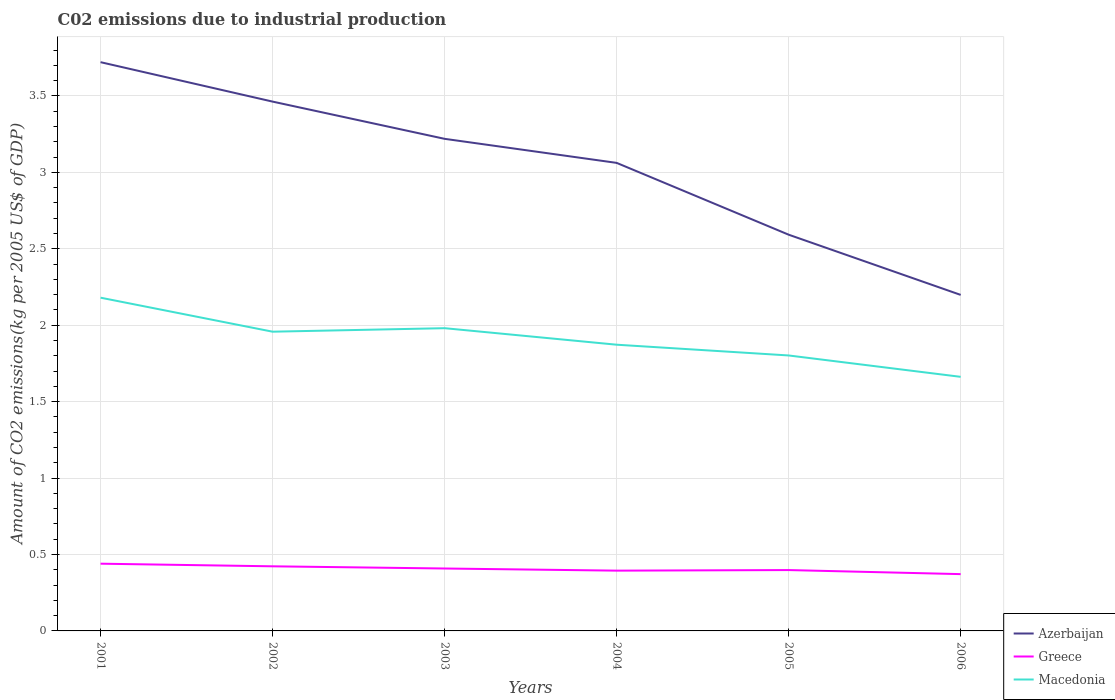How many different coloured lines are there?
Make the answer very short. 3. Does the line corresponding to Greece intersect with the line corresponding to Azerbaijan?
Your answer should be very brief. No. Across all years, what is the maximum amount of CO2 emitted due to industrial production in Macedonia?
Offer a terse response. 1.66. What is the total amount of CO2 emitted due to industrial production in Azerbaijan in the graph?
Your response must be concise. 1.52. What is the difference between the highest and the second highest amount of CO2 emitted due to industrial production in Greece?
Offer a very short reply. 0.07. What is the difference between the highest and the lowest amount of CO2 emitted due to industrial production in Greece?
Give a very brief answer. 3. How many lines are there?
Keep it short and to the point. 3. How many years are there in the graph?
Your answer should be compact. 6. What is the difference between two consecutive major ticks on the Y-axis?
Provide a short and direct response. 0.5. Does the graph contain any zero values?
Provide a short and direct response. No. Where does the legend appear in the graph?
Your response must be concise. Bottom right. How are the legend labels stacked?
Provide a succinct answer. Vertical. What is the title of the graph?
Offer a terse response. C02 emissions due to industrial production. Does "Poland" appear as one of the legend labels in the graph?
Give a very brief answer. No. What is the label or title of the X-axis?
Your answer should be very brief. Years. What is the label or title of the Y-axis?
Keep it short and to the point. Amount of CO2 emissions(kg per 2005 US$ of GDP). What is the Amount of CO2 emissions(kg per 2005 US$ of GDP) in Azerbaijan in 2001?
Make the answer very short. 3.72. What is the Amount of CO2 emissions(kg per 2005 US$ of GDP) of Greece in 2001?
Offer a terse response. 0.44. What is the Amount of CO2 emissions(kg per 2005 US$ of GDP) in Macedonia in 2001?
Offer a very short reply. 2.18. What is the Amount of CO2 emissions(kg per 2005 US$ of GDP) of Azerbaijan in 2002?
Keep it short and to the point. 3.46. What is the Amount of CO2 emissions(kg per 2005 US$ of GDP) in Greece in 2002?
Provide a short and direct response. 0.42. What is the Amount of CO2 emissions(kg per 2005 US$ of GDP) of Macedonia in 2002?
Your answer should be compact. 1.96. What is the Amount of CO2 emissions(kg per 2005 US$ of GDP) of Azerbaijan in 2003?
Offer a very short reply. 3.22. What is the Amount of CO2 emissions(kg per 2005 US$ of GDP) of Greece in 2003?
Make the answer very short. 0.41. What is the Amount of CO2 emissions(kg per 2005 US$ of GDP) of Macedonia in 2003?
Ensure brevity in your answer.  1.98. What is the Amount of CO2 emissions(kg per 2005 US$ of GDP) in Azerbaijan in 2004?
Offer a terse response. 3.06. What is the Amount of CO2 emissions(kg per 2005 US$ of GDP) in Greece in 2004?
Provide a succinct answer. 0.39. What is the Amount of CO2 emissions(kg per 2005 US$ of GDP) of Macedonia in 2004?
Keep it short and to the point. 1.87. What is the Amount of CO2 emissions(kg per 2005 US$ of GDP) in Azerbaijan in 2005?
Provide a succinct answer. 2.59. What is the Amount of CO2 emissions(kg per 2005 US$ of GDP) in Greece in 2005?
Your answer should be very brief. 0.4. What is the Amount of CO2 emissions(kg per 2005 US$ of GDP) in Macedonia in 2005?
Provide a short and direct response. 1.8. What is the Amount of CO2 emissions(kg per 2005 US$ of GDP) of Azerbaijan in 2006?
Your answer should be compact. 2.2. What is the Amount of CO2 emissions(kg per 2005 US$ of GDP) of Greece in 2006?
Ensure brevity in your answer.  0.37. What is the Amount of CO2 emissions(kg per 2005 US$ of GDP) of Macedonia in 2006?
Give a very brief answer. 1.66. Across all years, what is the maximum Amount of CO2 emissions(kg per 2005 US$ of GDP) in Azerbaijan?
Ensure brevity in your answer.  3.72. Across all years, what is the maximum Amount of CO2 emissions(kg per 2005 US$ of GDP) of Greece?
Ensure brevity in your answer.  0.44. Across all years, what is the maximum Amount of CO2 emissions(kg per 2005 US$ of GDP) of Macedonia?
Your answer should be very brief. 2.18. Across all years, what is the minimum Amount of CO2 emissions(kg per 2005 US$ of GDP) of Azerbaijan?
Make the answer very short. 2.2. Across all years, what is the minimum Amount of CO2 emissions(kg per 2005 US$ of GDP) of Greece?
Your response must be concise. 0.37. Across all years, what is the minimum Amount of CO2 emissions(kg per 2005 US$ of GDP) in Macedonia?
Make the answer very short. 1.66. What is the total Amount of CO2 emissions(kg per 2005 US$ of GDP) of Azerbaijan in the graph?
Give a very brief answer. 18.26. What is the total Amount of CO2 emissions(kg per 2005 US$ of GDP) in Greece in the graph?
Ensure brevity in your answer.  2.44. What is the total Amount of CO2 emissions(kg per 2005 US$ of GDP) in Macedonia in the graph?
Offer a terse response. 11.46. What is the difference between the Amount of CO2 emissions(kg per 2005 US$ of GDP) of Azerbaijan in 2001 and that in 2002?
Your answer should be very brief. 0.26. What is the difference between the Amount of CO2 emissions(kg per 2005 US$ of GDP) in Greece in 2001 and that in 2002?
Your response must be concise. 0.02. What is the difference between the Amount of CO2 emissions(kg per 2005 US$ of GDP) in Macedonia in 2001 and that in 2002?
Give a very brief answer. 0.22. What is the difference between the Amount of CO2 emissions(kg per 2005 US$ of GDP) of Azerbaijan in 2001 and that in 2003?
Keep it short and to the point. 0.5. What is the difference between the Amount of CO2 emissions(kg per 2005 US$ of GDP) in Greece in 2001 and that in 2003?
Provide a short and direct response. 0.03. What is the difference between the Amount of CO2 emissions(kg per 2005 US$ of GDP) of Macedonia in 2001 and that in 2003?
Your answer should be very brief. 0.2. What is the difference between the Amount of CO2 emissions(kg per 2005 US$ of GDP) in Azerbaijan in 2001 and that in 2004?
Offer a very short reply. 0.66. What is the difference between the Amount of CO2 emissions(kg per 2005 US$ of GDP) in Greece in 2001 and that in 2004?
Your answer should be compact. 0.05. What is the difference between the Amount of CO2 emissions(kg per 2005 US$ of GDP) in Macedonia in 2001 and that in 2004?
Offer a very short reply. 0.31. What is the difference between the Amount of CO2 emissions(kg per 2005 US$ of GDP) of Azerbaijan in 2001 and that in 2005?
Your response must be concise. 1.13. What is the difference between the Amount of CO2 emissions(kg per 2005 US$ of GDP) in Greece in 2001 and that in 2005?
Your response must be concise. 0.04. What is the difference between the Amount of CO2 emissions(kg per 2005 US$ of GDP) in Macedonia in 2001 and that in 2005?
Provide a succinct answer. 0.38. What is the difference between the Amount of CO2 emissions(kg per 2005 US$ of GDP) of Azerbaijan in 2001 and that in 2006?
Offer a very short reply. 1.52. What is the difference between the Amount of CO2 emissions(kg per 2005 US$ of GDP) of Greece in 2001 and that in 2006?
Your response must be concise. 0.07. What is the difference between the Amount of CO2 emissions(kg per 2005 US$ of GDP) in Macedonia in 2001 and that in 2006?
Your response must be concise. 0.52. What is the difference between the Amount of CO2 emissions(kg per 2005 US$ of GDP) in Azerbaijan in 2002 and that in 2003?
Give a very brief answer. 0.24. What is the difference between the Amount of CO2 emissions(kg per 2005 US$ of GDP) in Greece in 2002 and that in 2003?
Offer a terse response. 0.01. What is the difference between the Amount of CO2 emissions(kg per 2005 US$ of GDP) of Macedonia in 2002 and that in 2003?
Make the answer very short. -0.02. What is the difference between the Amount of CO2 emissions(kg per 2005 US$ of GDP) in Azerbaijan in 2002 and that in 2004?
Offer a terse response. 0.4. What is the difference between the Amount of CO2 emissions(kg per 2005 US$ of GDP) in Greece in 2002 and that in 2004?
Keep it short and to the point. 0.03. What is the difference between the Amount of CO2 emissions(kg per 2005 US$ of GDP) of Macedonia in 2002 and that in 2004?
Keep it short and to the point. 0.09. What is the difference between the Amount of CO2 emissions(kg per 2005 US$ of GDP) in Azerbaijan in 2002 and that in 2005?
Keep it short and to the point. 0.87. What is the difference between the Amount of CO2 emissions(kg per 2005 US$ of GDP) of Greece in 2002 and that in 2005?
Provide a short and direct response. 0.02. What is the difference between the Amount of CO2 emissions(kg per 2005 US$ of GDP) in Macedonia in 2002 and that in 2005?
Offer a very short reply. 0.16. What is the difference between the Amount of CO2 emissions(kg per 2005 US$ of GDP) in Azerbaijan in 2002 and that in 2006?
Offer a very short reply. 1.26. What is the difference between the Amount of CO2 emissions(kg per 2005 US$ of GDP) in Greece in 2002 and that in 2006?
Ensure brevity in your answer.  0.05. What is the difference between the Amount of CO2 emissions(kg per 2005 US$ of GDP) in Macedonia in 2002 and that in 2006?
Give a very brief answer. 0.3. What is the difference between the Amount of CO2 emissions(kg per 2005 US$ of GDP) in Azerbaijan in 2003 and that in 2004?
Provide a succinct answer. 0.16. What is the difference between the Amount of CO2 emissions(kg per 2005 US$ of GDP) in Greece in 2003 and that in 2004?
Provide a short and direct response. 0.01. What is the difference between the Amount of CO2 emissions(kg per 2005 US$ of GDP) of Macedonia in 2003 and that in 2004?
Your response must be concise. 0.11. What is the difference between the Amount of CO2 emissions(kg per 2005 US$ of GDP) in Azerbaijan in 2003 and that in 2005?
Offer a terse response. 0.63. What is the difference between the Amount of CO2 emissions(kg per 2005 US$ of GDP) in Greece in 2003 and that in 2005?
Make the answer very short. 0.01. What is the difference between the Amount of CO2 emissions(kg per 2005 US$ of GDP) in Macedonia in 2003 and that in 2005?
Offer a terse response. 0.18. What is the difference between the Amount of CO2 emissions(kg per 2005 US$ of GDP) of Azerbaijan in 2003 and that in 2006?
Your answer should be compact. 1.02. What is the difference between the Amount of CO2 emissions(kg per 2005 US$ of GDP) in Greece in 2003 and that in 2006?
Provide a succinct answer. 0.04. What is the difference between the Amount of CO2 emissions(kg per 2005 US$ of GDP) of Macedonia in 2003 and that in 2006?
Keep it short and to the point. 0.32. What is the difference between the Amount of CO2 emissions(kg per 2005 US$ of GDP) in Azerbaijan in 2004 and that in 2005?
Offer a very short reply. 0.47. What is the difference between the Amount of CO2 emissions(kg per 2005 US$ of GDP) of Greece in 2004 and that in 2005?
Provide a succinct answer. -0. What is the difference between the Amount of CO2 emissions(kg per 2005 US$ of GDP) of Macedonia in 2004 and that in 2005?
Keep it short and to the point. 0.07. What is the difference between the Amount of CO2 emissions(kg per 2005 US$ of GDP) in Azerbaijan in 2004 and that in 2006?
Ensure brevity in your answer.  0.86. What is the difference between the Amount of CO2 emissions(kg per 2005 US$ of GDP) in Greece in 2004 and that in 2006?
Your answer should be very brief. 0.02. What is the difference between the Amount of CO2 emissions(kg per 2005 US$ of GDP) of Macedonia in 2004 and that in 2006?
Keep it short and to the point. 0.21. What is the difference between the Amount of CO2 emissions(kg per 2005 US$ of GDP) of Azerbaijan in 2005 and that in 2006?
Make the answer very short. 0.39. What is the difference between the Amount of CO2 emissions(kg per 2005 US$ of GDP) in Greece in 2005 and that in 2006?
Offer a terse response. 0.03. What is the difference between the Amount of CO2 emissions(kg per 2005 US$ of GDP) of Macedonia in 2005 and that in 2006?
Offer a very short reply. 0.14. What is the difference between the Amount of CO2 emissions(kg per 2005 US$ of GDP) of Azerbaijan in 2001 and the Amount of CO2 emissions(kg per 2005 US$ of GDP) of Greece in 2002?
Your response must be concise. 3.3. What is the difference between the Amount of CO2 emissions(kg per 2005 US$ of GDP) of Azerbaijan in 2001 and the Amount of CO2 emissions(kg per 2005 US$ of GDP) of Macedonia in 2002?
Provide a succinct answer. 1.76. What is the difference between the Amount of CO2 emissions(kg per 2005 US$ of GDP) in Greece in 2001 and the Amount of CO2 emissions(kg per 2005 US$ of GDP) in Macedonia in 2002?
Provide a short and direct response. -1.52. What is the difference between the Amount of CO2 emissions(kg per 2005 US$ of GDP) in Azerbaijan in 2001 and the Amount of CO2 emissions(kg per 2005 US$ of GDP) in Greece in 2003?
Your response must be concise. 3.31. What is the difference between the Amount of CO2 emissions(kg per 2005 US$ of GDP) in Azerbaijan in 2001 and the Amount of CO2 emissions(kg per 2005 US$ of GDP) in Macedonia in 2003?
Offer a terse response. 1.74. What is the difference between the Amount of CO2 emissions(kg per 2005 US$ of GDP) of Greece in 2001 and the Amount of CO2 emissions(kg per 2005 US$ of GDP) of Macedonia in 2003?
Ensure brevity in your answer.  -1.54. What is the difference between the Amount of CO2 emissions(kg per 2005 US$ of GDP) of Azerbaijan in 2001 and the Amount of CO2 emissions(kg per 2005 US$ of GDP) of Greece in 2004?
Offer a very short reply. 3.33. What is the difference between the Amount of CO2 emissions(kg per 2005 US$ of GDP) of Azerbaijan in 2001 and the Amount of CO2 emissions(kg per 2005 US$ of GDP) of Macedonia in 2004?
Offer a terse response. 1.85. What is the difference between the Amount of CO2 emissions(kg per 2005 US$ of GDP) in Greece in 2001 and the Amount of CO2 emissions(kg per 2005 US$ of GDP) in Macedonia in 2004?
Provide a succinct answer. -1.43. What is the difference between the Amount of CO2 emissions(kg per 2005 US$ of GDP) in Azerbaijan in 2001 and the Amount of CO2 emissions(kg per 2005 US$ of GDP) in Greece in 2005?
Provide a succinct answer. 3.32. What is the difference between the Amount of CO2 emissions(kg per 2005 US$ of GDP) in Azerbaijan in 2001 and the Amount of CO2 emissions(kg per 2005 US$ of GDP) in Macedonia in 2005?
Make the answer very short. 1.92. What is the difference between the Amount of CO2 emissions(kg per 2005 US$ of GDP) of Greece in 2001 and the Amount of CO2 emissions(kg per 2005 US$ of GDP) of Macedonia in 2005?
Provide a short and direct response. -1.36. What is the difference between the Amount of CO2 emissions(kg per 2005 US$ of GDP) of Azerbaijan in 2001 and the Amount of CO2 emissions(kg per 2005 US$ of GDP) of Greece in 2006?
Your response must be concise. 3.35. What is the difference between the Amount of CO2 emissions(kg per 2005 US$ of GDP) in Azerbaijan in 2001 and the Amount of CO2 emissions(kg per 2005 US$ of GDP) in Macedonia in 2006?
Your answer should be very brief. 2.06. What is the difference between the Amount of CO2 emissions(kg per 2005 US$ of GDP) of Greece in 2001 and the Amount of CO2 emissions(kg per 2005 US$ of GDP) of Macedonia in 2006?
Your response must be concise. -1.22. What is the difference between the Amount of CO2 emissions(kg per 2005 US$ of GDP) of Azerbaijan in 2002 and the Amount of CO2 emissions(kg per 2005 US$ of GDP) of Greece in 2003?
Offer a terse response. 3.05. What is the difference between the Amount of CO2 emissions(kg per 2005 US$ of GDP) in Azerbaijan in 2002 and the Amount of CO2 emissions(kg per 2005 US$ of GDP) in Macedonia in 2003?
Your response must be concise. 1.48. What is the difference between the Amount of CO2 emissions(kg per 2005 US$ of GDP) in Greece in 2002 and the Amount of CO2 emissions(kg per 2005 US$ of GDP) in Macedonia in 2003?
Your answer should be very brief. -1.56. What is the difference between the Amount of CO2 emissions(kg per 2005 US$ of GDP) of Azerbaijan in 2002 and the Amount of CO2 emissions(kg per 2005 US$ of GDP) of Greece in 2004?
Your answer should be very brief. 3.07. What is the difference between the Amount of CO2 emissions(kg per 2005 US$ of GDP) in Azerbaijan in 2002 and the Amount of CO2 emissions(kg per 2005 US$ of GDP) in Macedonia in 2004?
Your response must be concise. 1.59. What is the difference between the Amount of CO2 emissions(kg per 2005 US$ of GDP) of Greece in 2002 and the Amount of CO2 emissions(kg per 2005 US$ of GDP) of Macedonia in 2004?
Offer a very short reply. -1.45. What is the difference between the Amount of CO2 emissions(kg per 2005 US$ of GDP) of Azerbaijan in 2002 and the Amount of CO2 emissions(kg per 2005 US$ of GDP) of Greece in 2005?
Your answer should be compact. 3.06. What is the difference between the Amount of CO2 emissions(kg per 2005 US$ of GDP) in Azerbaijan in 2002 and the Amount of CO2 emissions(kg per 2005 US$ of GDP) in Macedonia in 2005?
Your answer should be very brief. 1.66. What is the difference between the Amount of CO2 emissions(kg per 2005 US$ of GDP) of Greece in 2002 and the Amount of CO2 emissions(kg per 2005 US$ of GDP) of Macedonia in 2005?
Your answer should be very brief. -1.38. What is the difference between the Amount of CO2 emissions(kg per 2005 US$ of GDP) of Azerbaijan in 2002 and the Amount of CO2 emissions(kg per 2005 US$ of GDP) of Greece in 2006?
Provide a succinct answer. 3.09. What is the difference between the Amount of CO2 emissions(kg per 2005 US$ of GDP) in Azerbaijan in 2002 and the Amount of CO2 emissions(kg per 2005 US$ of GDP) in Macedonia in 2006?
Provide a short and direct response. 1.8. What is the difference between the Amount of CO2 emissions(kg per 2005 US$ of GDP) in Greece in 2002 and the Amount of CO2 emissions(kg per 2005 US$ of GDP) in Macedonia in 2006?
Your response must be concise. -1.24. What is the difference between the Amount of CO2 emissions(kg per 2005 US$ of GDP) in Azerbaijan in 2003 and the Amount of CO2 emissions(kg per 2005 US$ of GDP) in Greece in 2004?
Your answer should be very brief. 2.83. What is the difference between the Amount of CO2 emissions(kg per 2005 US$ of GDP) in Azerbaijan in 2003 and the Amount of CO2 emissions(kg per 2005 US$ of GDP) in Macedonia in 2004?
Offer a very short reply. 1.35. What is the difference between the Amount of CO2 emissions(kg per 2005 US$ of GDP) of Greece in 2003 and the Amount of CO2 emissions(kg per 2005 US$ of GDP) of Macedonia in 2004?
Your answer should be compact. -1.46. What is the difference between the Amount of CO2 emissions(kg per 2005 US$ of GDP) of Azerbaijan in 2003 and the Amount of CO2 emissions(kg per 2005 US$ of GDP) of Greece in 2005?
Provide a short and direct response. 2.82. What is the difference between the Amount of CO2 emissions(kg per 2005 US$ of GDP) of Azerbaijan in 2003 and the Amount of CO2 emissions(kg per 2005 US$ of GDP) of Macedonia in 2005?
Provide a short and direct response. 1.42. What is the difference between the Amount of CO2 emissions(kg per 2005 US$ of GDP) of Greece in 2003 and the Amount of CO2 emissions(kg per 2005 US$ of GDP) of Macedonia in 2005?
Give a very brief answer. -1.39. What is the difference between the Amount of CO2 emissions(kg per 2005 US$ of GDP) of Azerbaijan in 2003 and the Amount of CO2 emissions(kg per 2005 US$ of GDP) of Greece in 2006?
Provide a succinct answer. 2.85. What is the difference between the Amount of CO2 emissions(kg per 2005 US$ of GDP) in Azerbaijan in 2003 and the Amount of CO2 emissions(kg per 2005 US$ of GDP) in Macedonia in 2006?
Your answer should be compact. 1.56. What is the difference between the Amount of CO2 emissions(kg per 2005 US$ of GDP) of Greece in 2003 and the Amount of CO2 emissions(kg per 2005 US$ of GDP) of Macedonia in 2006?
Give a very brief answer. -1.25. What is the difference between the Amount of CO2 emissions(kg per 2005 US$ of GDP) in Azerbaijan in 2004 and the Amount of CO2 emissions(kg per 2005 US$ of GDP) in Greece in 2005?
Offer a very short reply. 2.66. What is the difference between the Amount of CO2 emissions(kg per 2005 US$ of GDP) of Azerbaijan in 2004 and the Amount of CO2 emissions(kg per 2005 US$ of GDP) of Macedonia in 2005?
Give a very brief answer. 1.26. What is the difference between the Amount of CO2 emissions(kg per 2005 US$ of GDP) in Greece in 2004 and the Amount of CO2 emissions(kg per 2005 US$ of GDP) in Macedonia in 2005?
Keep it short and to the point. -1.41. What is the difference between the Amount of CO2 emissions(kg per 2005 US$ of GDP) in Azerbaijan in 2004 and the Amount of CO2 emissions(kg per 2005 US$ of GDP) in Greece in 2006?
Ensure brevity in your answer.  2.69. What is the difference between the Amount of CO2 emissions(kg per 2005 US$ of GDP) of Azerbaijan in 2004 and the Amount of CO2 emissions(kg per 2005 US$ of GDP) of Macedonia in 2006?
Ensure brevity in your answer.  1.4. What is the difference between the Amount of CO2 emissions(kg per 2005 US$ of GDP) of Greece in 2004 and the Amount of CO2 emissions(kg per 2005 US$ of GDP) of Macedonia in 2006?
Provide a succinct answer. -1.27. What is the difference between the Amount of CO2 emissions(kg per 2005 US$ of GDP) in Azerbaijan in 2005 and the Amount of CO2 emissions(kg per 2005 US$ of GDP) in Greece in 2006?
Your answer should be very brief. 2.22. What is the difference between the Amount of CO2 emissions(kg per 2005 US$ of GDP) in Greece in 2005 and the Amount of CO2 emissions(kg per 2005 US$ of GDP) in Macedonia in 2006?
Ensure brevity in your answer.  -1.26. What is the average Amount of CO2 emissions(kg per 2005 US$ of GDP) of Azerbaijan per year?
Offer a very short reply. 3.04. What is the average Amount of CO2 emissions(kg per 2005 US$ of GDP) in Greece per year?
Keep it short and to the point. 0.41. What is the average Amount of CO2 emissions(kg per 2005 US$ of GDP) of Macedonia per year?
Your answer should be compact. 1.91. In the year 2001, what is the difference between the Amount of CO2 emissions(kg per 2005 US$ of GDP) of Azerbaijan and Amount of CO2 emissions(kg per 2005 US$ of GDP) of Greece?
Your answer should be very brief. 3.28. In the year 2001, what is the difference between the Amount of CO2 emissions(kg per 2005 US$ of GDP) of Azerbaijan and Amount of CO2 emissions(kg per 2005 US$ of GDP) of Macedonia?
Make the answer very short. 1.54. In the year 2001, what is the difference between the Amount of CO2 emissions(kg per 2005 US$ of GDP) in Greece and Amount of CO2 emissions(kg per 2005 US$ of GDP) in Macedonia?
Your answer should be compact. -1.74. In the year 2002, what is the difference between the Amount of CO2 emissions(kg per 2005 US$ of GDP) in Azerbaijan and Amount of CO2 emissions(kg per 2005 US$ of GDP) in Greece?
Ensure brevity in your answer.  3.04. In the year 2002, what is the difference between the Amount of CO2 emissions(kg per 2005 US$ of GDP) in Azerbaijan and Amount of CO2 emissions(kg per 2005 US$ of GDP) in Macedonia?
Offer a terse response. 1.51. In the year 2002, what is the difference between the Amount of CO2 emissions(kg per 2005 US$ of GDP) of Greece and Amount of CO2 emissions(kg per 2005 US$ of GDP) of Macedonia?
Your answer should be very brief. -1.54. In the year 2003, what is the difference between the Amount of CO2 emissions(kg per 2005 US$ of GDP) of Azerbaijan and Amount of CO2 emissions(kg per 2005 US$ of GDP) of Greece?
Your response must be concise. 2.81. In the year 2003, what is the difference between the Amount of CO2 emissions(kg per 2005 US$ of GDP) of Azerbaijan and Amount of CO2 emissions(kg per 2005 US$ of GDP) of Macedonia?
Make the answer very short. 1.24. In the year 2003, what is the difference between the Amount of CO2 emissions(kg per 2005 US$ of GDP) in Greece and Amount of CO2 emissions(kg per 2005 US$ of GDP) in Macedonia?
Keep it short and to the point. -1.57. In the year 2004, what is the difference between the Amount of CO2 emissions(kg per 2005 US$ of GDP) in Azerbaijan and Amount of CO2 emissions(kg per 2005 US$ of GDP) in Greece?
Your response must be concise. 2.67. In the year 2004, what is the difference between the Amount of CO2 emissions(kg per 2005 US$ of GDP) in Azerbaijan and Amount of CO2 emissions(kg per 2005 US$ of GDP) in Macedonia?
Provide a short and direct response. 1.19. In the year 2004, what is the difference between the Amount of CO2 emissions(kg per 2005 US$ of GDP) in Greece and Amount of CO2 emissions(kg per 2005 US$ of GDP) in Macedonia?
Keep it short and to the point. -1.48. In the year 2005, what is the difference between the Amount of CO2 emissions(kg per 2005 US$ of GDP) of Azerbaijan and Amount of CO2 emissions(kg per 2005 US$ of GDP) of Greece?
Your answer should be very brief. 2.19. In the year 2005, what is the difference between the Amount of CO2 emissions(kg per 2005 US$ of GDP) of Azerbaijan and Amount of CO2 emissions(kg per 2005 US$ of GDP) of Macedonia?
Make the answer very short. 0.79. In the year 2005, what is the difference between the Amount of CO2 emissions(kg per 2005 US$ of GDP) of Greece and Amount of CO2 emissions(kg per 2005 US$ of GDP) of Macedonia?
Your answer should be compact. -1.4. In the year 2006, what is the difference between the Amount of CO2 emissions(kg per 2005 US$ of GDP) in Azerbaijan and Amount of CO2 emissions(kg per 2005 US$ of GDP) in Greece?
Provide a succinct answer. 1.83. In the year 2006, what is the difference between the Amount of CO2 emissions(kg per 2005 US$ of GDP) of Azerbaijan and Amount of CO2 emissions(kg per 2005 US$ of GDP) of Macedonia?
Your answer should be compact. 0.54. In the year 2006, what is the difference between the Amount of CO2 emissions(kg per 2005 US$ of GDP) of Greece and Amount of CO2 emissions(kg per 2005 US$ of GDP) of Macedonia?
Your answer should be compact. -1.29. What is the ratio of the Amount of CO2 emissions(kg per 2005 US$ of GDP) in Azerbaijan in 2001 to that in 2002?
Offer a terse response. 1.07. What is the ratio of the Amount of CO2 emissions(kg per 2005 US$ of GDP) of Greece in 2001 to that in 2002?
Make the answer very short. 1.04. What is the ratio of the Amount of CO2 emissions(kg per 2005 US$ of GDP) of Macedonia in 2001 to that in 2002?
Your answer should be very brief. 1.11. What is the ratio of the Amount of CO2 emissions(kg per 2005 US$ of GDP) of Azerbaijan in 2001 to that in 2003?
Provide a succinct answer. 1.16. What is the ratio of the Amount of CO2 emissions(kg per 2005 US$ of GDP) in Greece in 2001 to that in 2003?
Ensure brevity in your answer.  1.08. What is the ratio of the Amount of CO2 emissions(kg per 2005 US$ of GDP) of Macedonia in 2001 to that in 2003?
Your answer should be compact. 1.1. What is the ratio of the Amount of CO2 emissions(kg per 2005 US$ of GDP) in Azerbaijan in 2001 to that in 2004?
Ensure brevity in your answer.  1.22. What is the ratio of the Amount of CO2 emissions(kg per 2005 US$ of GDP) of Greece in 2001 to that in 2004?
Provide a short and direct response. 1.12. What is the ratio of the Amount of CO2 emissions(kg per 2005 US$ of GDP) in Macedonia in 2001 to that in 2004?
Keep it short and to the point. 1.16. What is the ratio of the Amount of CO2 emissions(kg per 2005 US$ of GDP) in Azerbaijan in 2001 to that in 2005?
Your answer should be compact. 1.44. What is the ratio of the Amount of CO2 emissions(kg per 2005 US$ of GDP) in Greece in 2001 to that in 2005?
Provide a succinct answer. 1.1. What is the ratio of the Amount of CO2 emissions(kg per 2005 US$ of GDP) of Macedonia in 2001 to that in 2005?
Your answer should be very brief. 1.21. What is the ratio of the Amount of CO2 emissions(kg per 2005 US$ of GDP) of Azerbaijan in 2001 to that in 2006?
Ensure brevity in your answer.  1.69. What is the ratio of the Amount of CO2 emissions(kg per 2005 US$ of GDP) of Greece in 2001 to that in 2006?
Offer a very short reply. 1.18. What is the ratio of the Amount of CO2 emissions(kg per 2005 US$ of GDP) in Macedonia in 2001 to that in 2006?
Your answer should be compact. 1.31. What is the ratio of the Amount of CO2 emissions(kg per 2005 US$ of GDP) in Azerbaijan in 2002 to that in 2003?
Provide a short and direct response. 1.08. What is the ratio of the Amount of CO2 emissions(kg per 2005 US$ of GDP) of Greece in 2002 to that in 2003?
Your answer should be very brief. 1.04. What is the ratio of the Amount of CO2 emissions(kg per 2005 US$ of GDP) in Macedonia in 2002 to that in 2003?
Your answer should be compact. 0.99. What is the ratio of the Amount of CO2 emissions(kg per 2005 US$ of GDP) of Azerbaijan in 2002 to that in 2004?
Offer a very short reply. 1.13. What is the ratio of the Amount of CO2 emissions(kg per 2005 US$ of GDP) in Greece in 2002 to that in 2004?
Provide a succinct answer. 1.07. What is the ratio of the Amount of CO2 emissions(kg per 2005 US$ of GDP) in Macedonia in 2002 to that in 2004?
Give a very brief answer. 1.05. What is the ratio of the Amount of CO2 emissions(kg per 2005 US$ of GDP) of Azerbaijan in 2002 to that in 2005?
Make the answer very short. 1.34. What is the ratio of the Amount of CO2 emissions(kg per 2005 US$ of GDP) in Greece in 2002 to that in 2005?
Give a very brief answer. 1.06. What is the ratio of the Amount of CO2 emissions(kg per 2005 US$ of GDP) of Macedonia in 2002 to that in 2005?
Offer a very short reply. 1.09. What is the ratio of the Amount of CO2 emissions(kg per 2005 US$ of GDP) in Azerbaijan in 2002 to that in 2006?
Give a very brief answer. 1.58. What is the ratio of the Amount of CO2 emissions(kg per 2005 US$ of GDP) in Greece in 2002 to that in 2006?
Offer a very short reply. 1.14. What is the ratio of the Amount of CO2 emissions(kg per 2005 US$ of GDP) of Macedonia in 2002 to that in 2006?
Make the answer very short. 1.18. What is the ratio of the Amount of CO2 emissions(kg per 2005 US$ of GDP) of Azerbaijan in 2003 to that in 2004?
Offer a terse response. 1.05. What is the ratio of the Amount of CO2 emissions(kg per 2005 US$ of GDP) in Greece in 2003 to that in 2004?
Provide a succinct answer. 1.04. What is the ratio of the Amount of CO2 emissions(kg per 2005 US$ of GDP) in Macedonia in 2003 to that in 2004?
Provide a succinct answer. 1.06. What is the ratio of the Amount of CO2 emissions(kg per 2005 US$ of GDP) in Azerbaijan in 2003 to that in 2005?
Provide a short and direct response. 1.24. What is the ratio of the Amount of CO2 emissions(kg per 2005 US$ of GDP) in Greece in 2003 to that in 2005?
Your answer should be very brief. 1.03. What is the ratio of the Amount of CO2 emissions(kg per 2005 US$ of GDP) of Macedonia in 2003 to that in 2005?
Your answer should be compact. 1.1. What is the ratio of the Amount of CO2 emissions(kg per 2005 US$ of GDP) of Azerbaijan in 2003 to that in 2006?
Make the answer very short. 1.46. What is the ratio of the Amount of CO2 emissions(kg per 2005 US$ of GDP) in Greece in 2003 to that in 2006?
Offer a terse response. 1.1. What is the ratio of the Amount of CO2 emissions(kg per 2005 US$ of GDP) in Macedonia in 2003 to that in 2006?
Keep it short and to the point. 1.19. What is the ratio of the Amount of CO2 emissions(kg per 2005 US$ of GDP) of Azerbaijan in 2004 to that in 2005?
Provide a short and direct response. 1.18. What is the ratio of the Amount of CO2 emissions(kg per 2005 US$ of GDP) in Greece in 2004 to that in 2005?
Make the answer very short. 0.99. What is the ratio of the Amount of CO2 emissions(kg per 2005 US$ of GDP) of Macedonia in 2004 to that in 2005?
Your response must be concise. 1.04. What is the ratio of the Amount of CO2 emissions(kg per 2005 US$ of GDP) in Azerbaijan in 2004 to that in 2006?
Give a very brief answer. 1.39. What is the ratio of the Amount of CO2 emissions(kg per 2005 US$ of GDP) of Greece in 2004 to that in 2006?
Ensure brevity in your answer.  1.06. What is the ratio of the Amount of CO2 emissions(kg per 2005 US$ of GDP) in Macedonia in 2004 to that in 2006?
Your response must be concise. 1.13. What is the ratio of the Amount of CO2 emissions(kg per 2005 US$ of GDP) of Azerbaijan in 2005 to that in 2006?
Your response must be concise. 1.18. What is the ratio of the Amount of CO2 emissions(kg per 2005 US$ of GDP) in Greece in 2005 to that in 2006?
Offer a very short reply. 1.07. What is the ratio of the Amount of CO2 emissions(kg per 2005 US$ of GDP) of Macedonia in 2005 to that in 2006?
Provide a short and direct response. 1.08. What is the difference between the highest and the second highest Amount of CO2 emissions(kg per 2005 US$ of GDP) of Azerbaijan?
Give a very brief answer. 0.26. What is the difference between the highest and the second highest Amount of CO2 emissions(kg per 2005 US$ of GDP) of Greece?
Your answer should be very brief. 0.02. What is the difference between the highest and the second highest Amount of CO2 emissions(kg per 2005 US$ of GDP) in Macedonia?
Offer a terse response. 0.2. What is the difference between the highest and the lowest Amount of CO2 emissions(kg per 2005 US$ of GDP) in Azerbaijan?
Ensure brevity in your answer.  1.52. What is the difference between the highest and the lowest Amount of CO2 emissions(kg per 2005 US$ of GDP) of Greece?
Offer a very short reply. 0.07. What is the difference between the highest and the lowest Amount of CO2 emissions(kg per 2005 US$ of GDP) in Macedonia?
Ensure brevity in your answer.  0.52. 